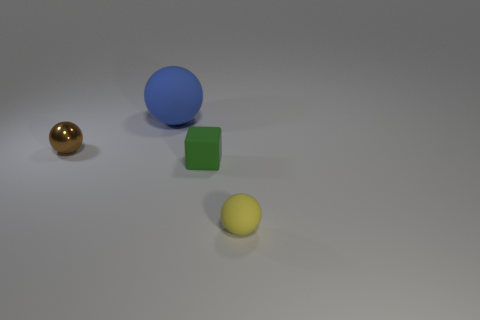Subtract all matte balls. How many balls are left? 1 Subtract all brown spheres. How many spheres are left? 2 Subtract all cubes. How many objects are left? 3 Subtract 2 balls. How many balls are left? 1 Add 3 small green rubber cubes. How many objects exist? 7 Subtract 0 purple cubes. How many objects are left? 4 Subtract all green balls. Subtract all purple cylinders. How many balls are left? 3 Subtract all blue spheres. How many red cubes are left? 0 Subtract all tiny green things. Subtract all large brown rubber things. How many objects are left? 3 Add 2 large blue balls. How many large blue balls are left? 3 